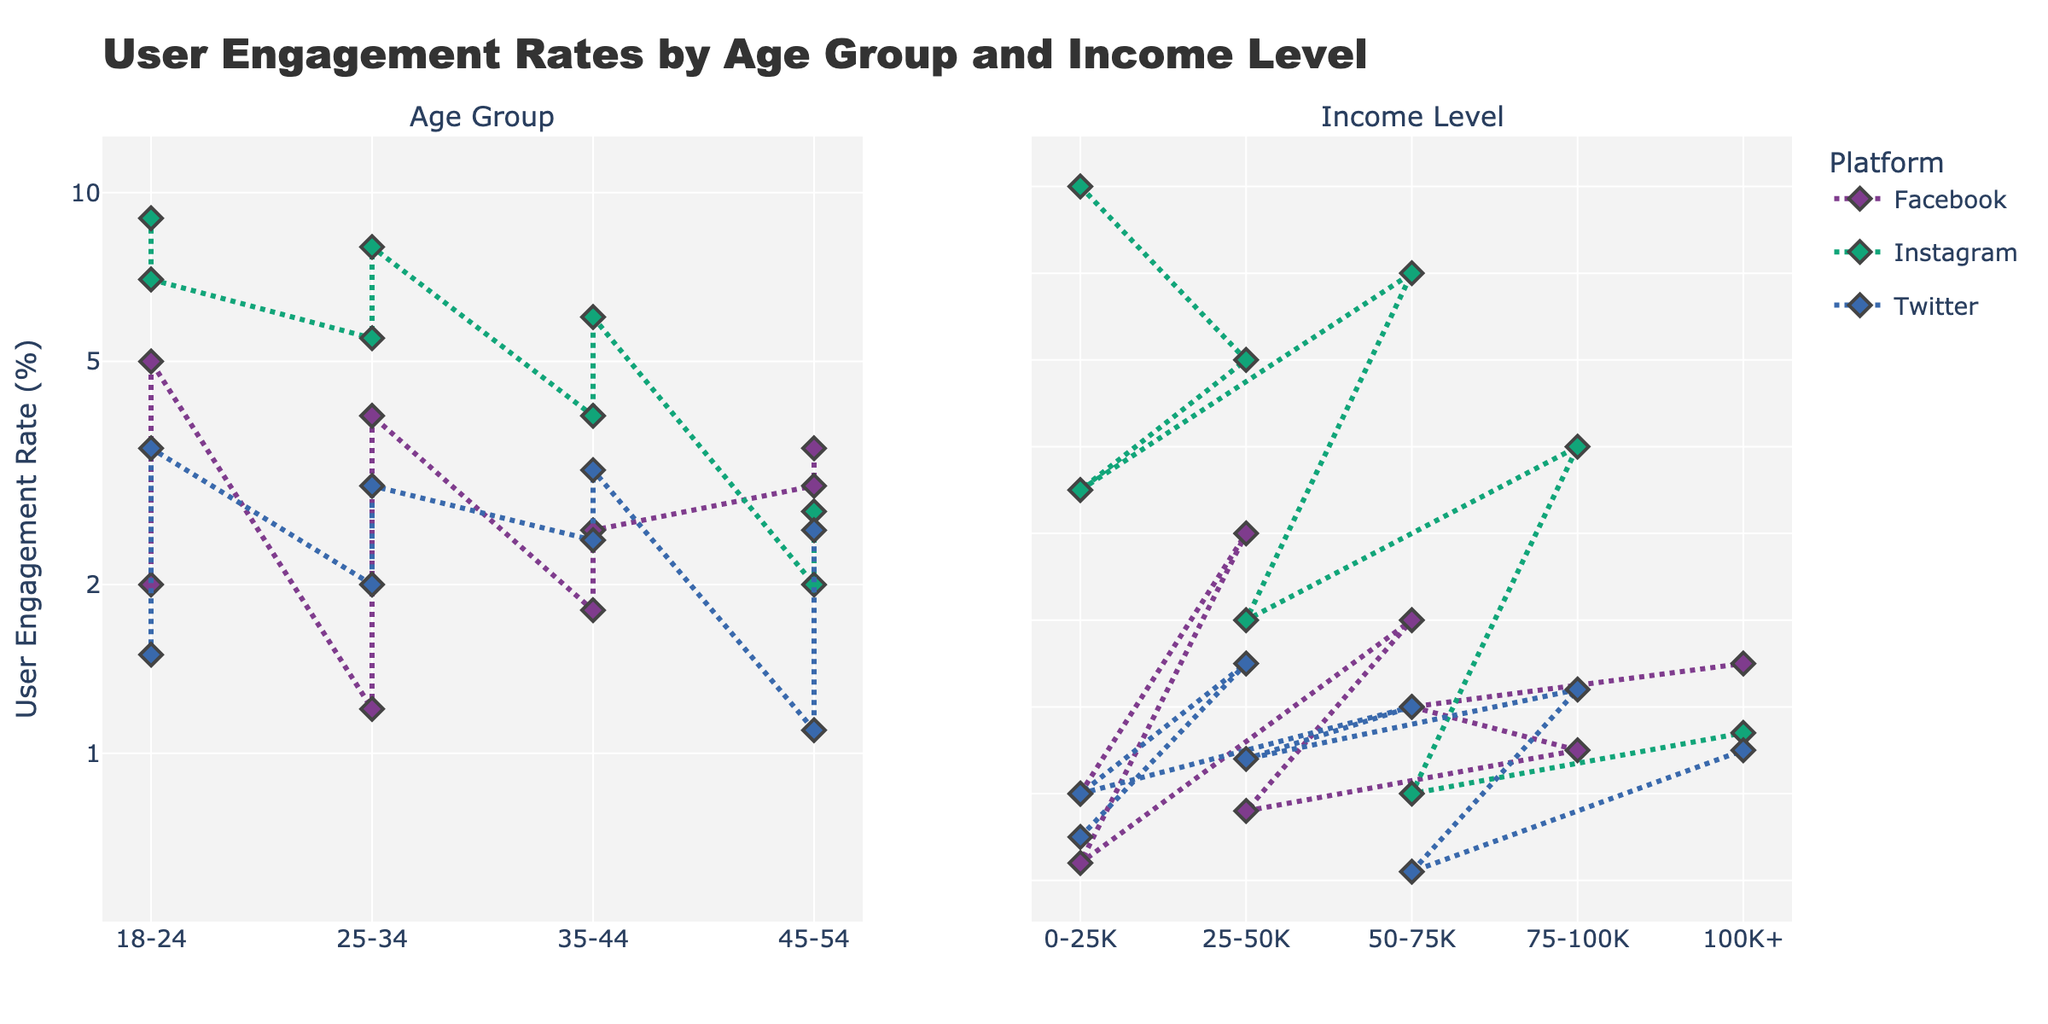What is the title of the figure? The title of the figure is prominently displayed at the top and reads "User Engagement Rates by Age Group and Income Level".
Answer: User Engagement Rates by Age Group and Income Level Which social media platform shows the highest user engagement rate for the 18-24 age group with an income level of 0-25K? By looking at the markers and lines in the subplot on the left (Age Group), for the 18-24 age group and income level of 0-25K, the platform with the highest engagement rate is Instagram, which is shown to be 9%.
Answer: Instagram Across all the income levels, which social media platform has the lowest user engagement rate in the 25-34 age group? To find this, we review the subplot on the left (Age Group). For the age group 25-34, the lowest engagement rate appears to be on Facebook with a user engagement rate of 1.2%.
Answer: Facebook Comparing engagement rates, how does Instagram perform versus Facebook in the 18-24 and 25-34 age groups with an income level of 0-25K? For the 18-24 age group with 0-25K income, Instagram has an engagement rate of 9%, while Facebook has 2%. For the 25-34 age group with the same income level, Instagram has 5.5%, while Facebook has 1.2%. In both cases, Instagram outperforms Facebook.
Answer: Instagram outperforms Facebook in both cases What is the trend of user engagement rate for Twitter when moving from the 35-44 age group to the 45-54 age group across all income levels? First, find the engagement rates for Twitter in each age group across their respective income levels in both subplots. For 35-44, the rates are 2.4 and 3.2. For 45-54, the rates are 1.1 and 2.5. Observing these, there's a general decrease in user engagement rate for Twitter when moving from 35-44 to 45-54.
Answer: Decreasing trend Which age group shows the highest engagement rate for any social media platform, and which platform is it? Review both subplots for each age group to identify the highest engagement rate overall. The highest engagement rate is for Instagram in the 18-24 age group with an income level of 0-25K, which is 9%.
Answer: 18-24, Instagram What is the median user engagement rate for Facebook across all income levels and age groups? List the engagement rates for Facebook: 2, 5, 1.2, 4, 1.8, 2.5, 3, 3.5. There are 8 values, so the median is the average of the 4th and 5th values after sorting: (2.5 + 3)/2 = 2.75.
Answer: 2.75 Which social media platform has the most consistent user engagement rate across different age groups and income levels? Consistency means the smallest deviation across values. Review each platform comparison for consistency in both subplots. Twitter appears most consistent with engagement rates ranging tightest across age groups and income levels: within the range of 1.1 to 3.5.
Answer: Twitter 